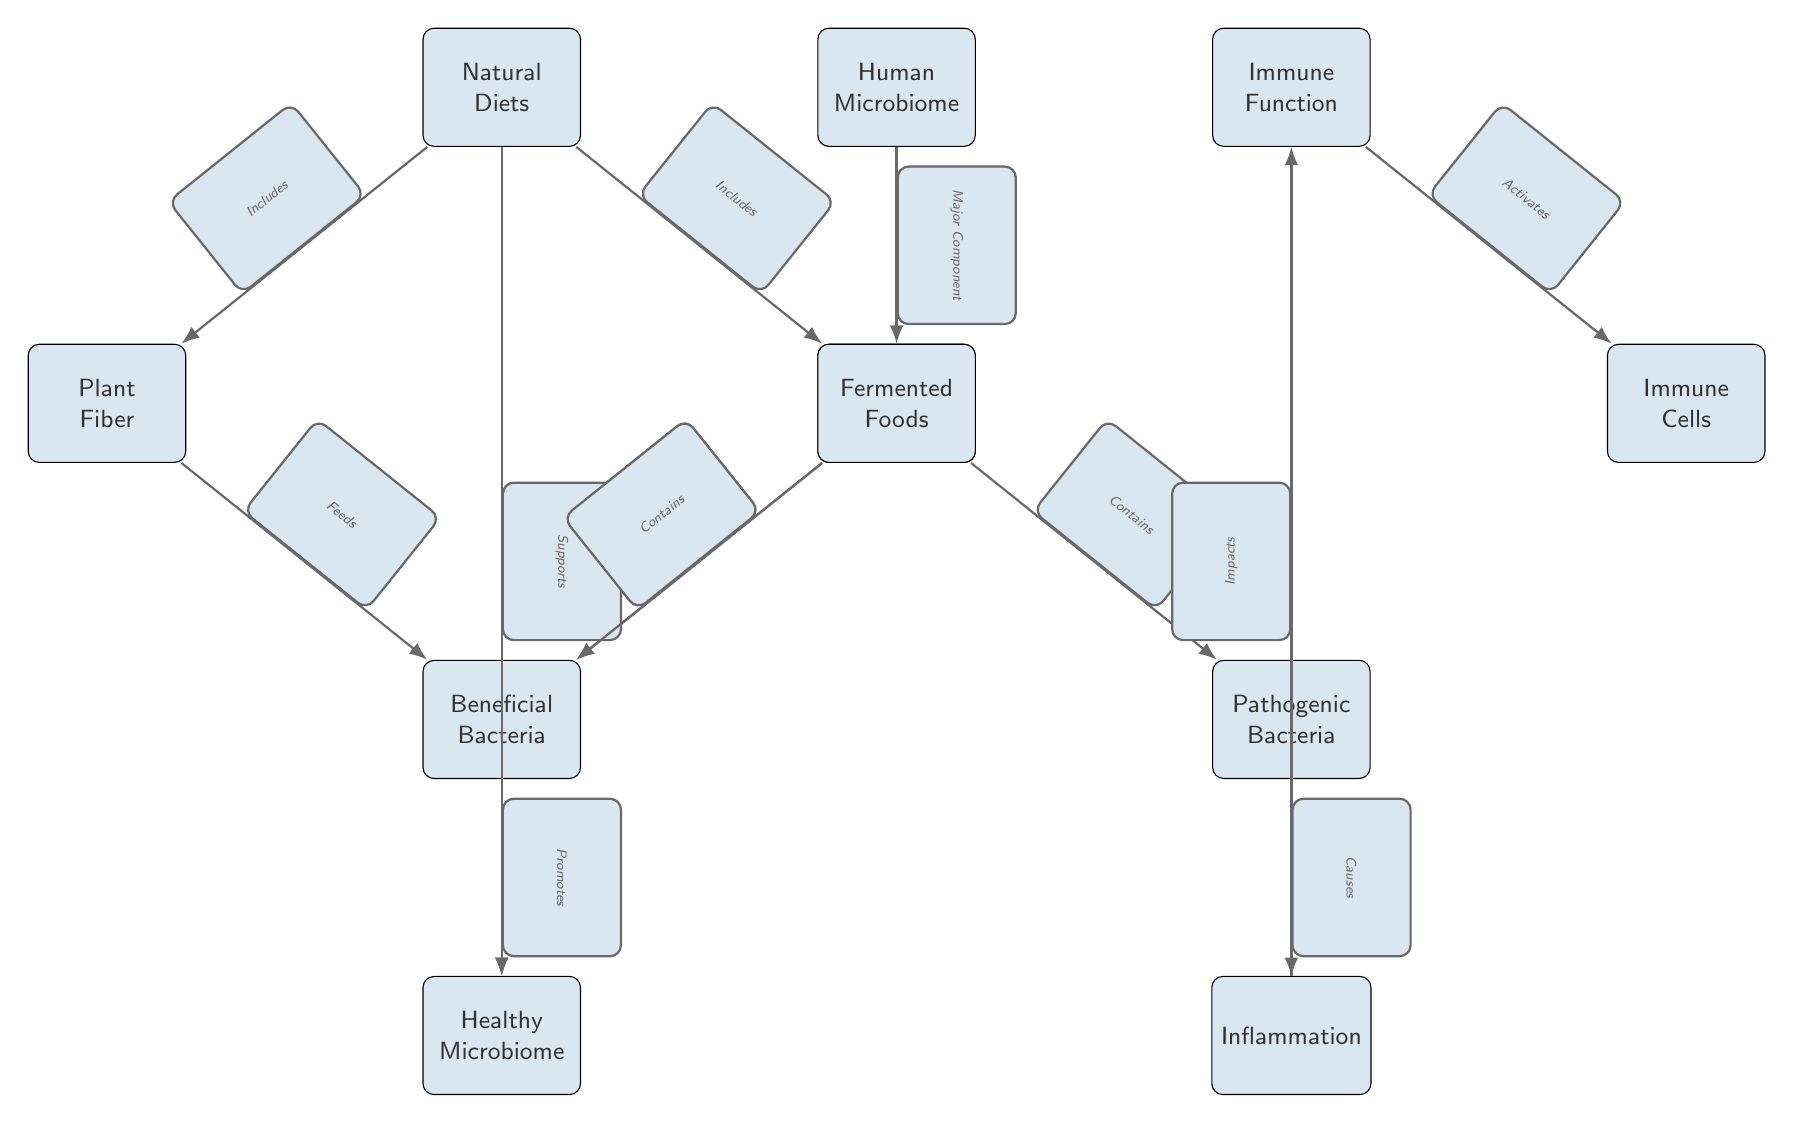What are the two main components of the Gut? The diagram shows that the Gut contains two main components: Beneficial Bacteria and Pathogenic Bacteria. Both nodes are directly connected to the Gut node.
Answer: Beneficial Bacteria and Pathogenic Bacteria How does Natural Diets affect the Healthy Microbiome? The diagram indicates a direct connection where Natural Diets support a Healthy Microbiome. This relationship shows the role of diet in maintaining microbial health.
Answer: Supports What effect do Pathogenic Bacteria have in the diagram? The diagram illustrates that Pathogenic Bacteria causes Inflammation, indicating their negative impact. This causal relationship is represented by the edge connecting the two nodes.
Answer: Causes Which type of bacteria promotes a Healthy Microbiome? According to the diagram, Beneficial Bacteria promote a Healthy Microbiome, highlighting their positive role within the ecosystem.
Answer: Beneficial Bacteria What does Plant Fiber do in relation to Beneficial Bacteria? The diagram shows that Plant Fiber feeds Beneficial Bacteria, which describes how plant-based diets nourish good bacteria in the gut.
Answer: Feeds How do Immune Cells relate to Immune Function? The diagram indicates that Immune Cells are activated by Immune Function, establishing a link between these two concepts in immune response mechanisms.
Answer: Activates What types of food are included in Natural Diets? The diagram lists the two types of food that Natural Diets include: Plant Fiber and Fermented Foods. This is shown in the edges that connect Natural Diets to these components.
Answer: Plant Fiber and Fermented Foods How many nodes are connected to the Gut? The Gut is connected to three nodes: Beneficial Bacteria, Pathogenic Bacteria, and Healthy Microbiome. By counting these connections, we determine the total number of nodes linked to it.
Answer: 3 What impact does Inflammation have in the context of Immune Function? The diagram indicates that Inflammation impacts Immune Function, suggesting that inflammation can have deleterious effects on the immune system. This relationship is expressed with a direct edge indicating its influence.
Answer: Impacts 